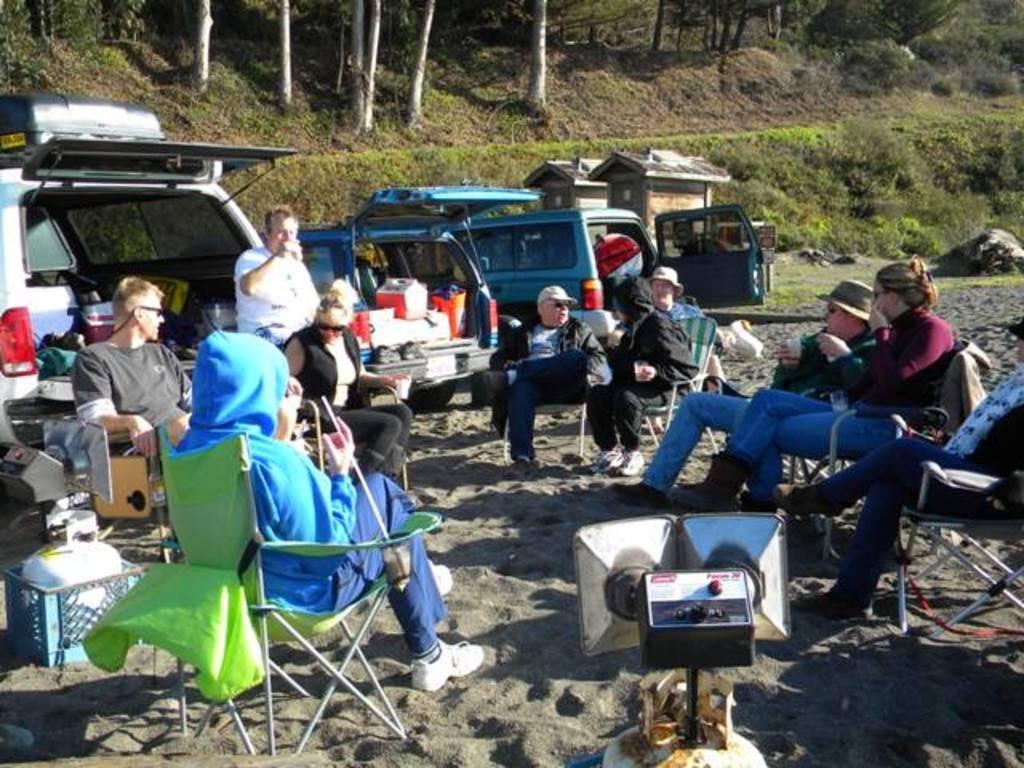In one or two sentences, can you explain what this image depicts? Here in this picture we can see a group of people sitting on chairs over a place and we can see speakers also present and we can see they are wearing caps, goggles and hats on them and we can also see vehicles present behind them over there and we can see some part of ground is covered with grass, plants and trees all over there and we can also see baskets and luggage also present over there. 